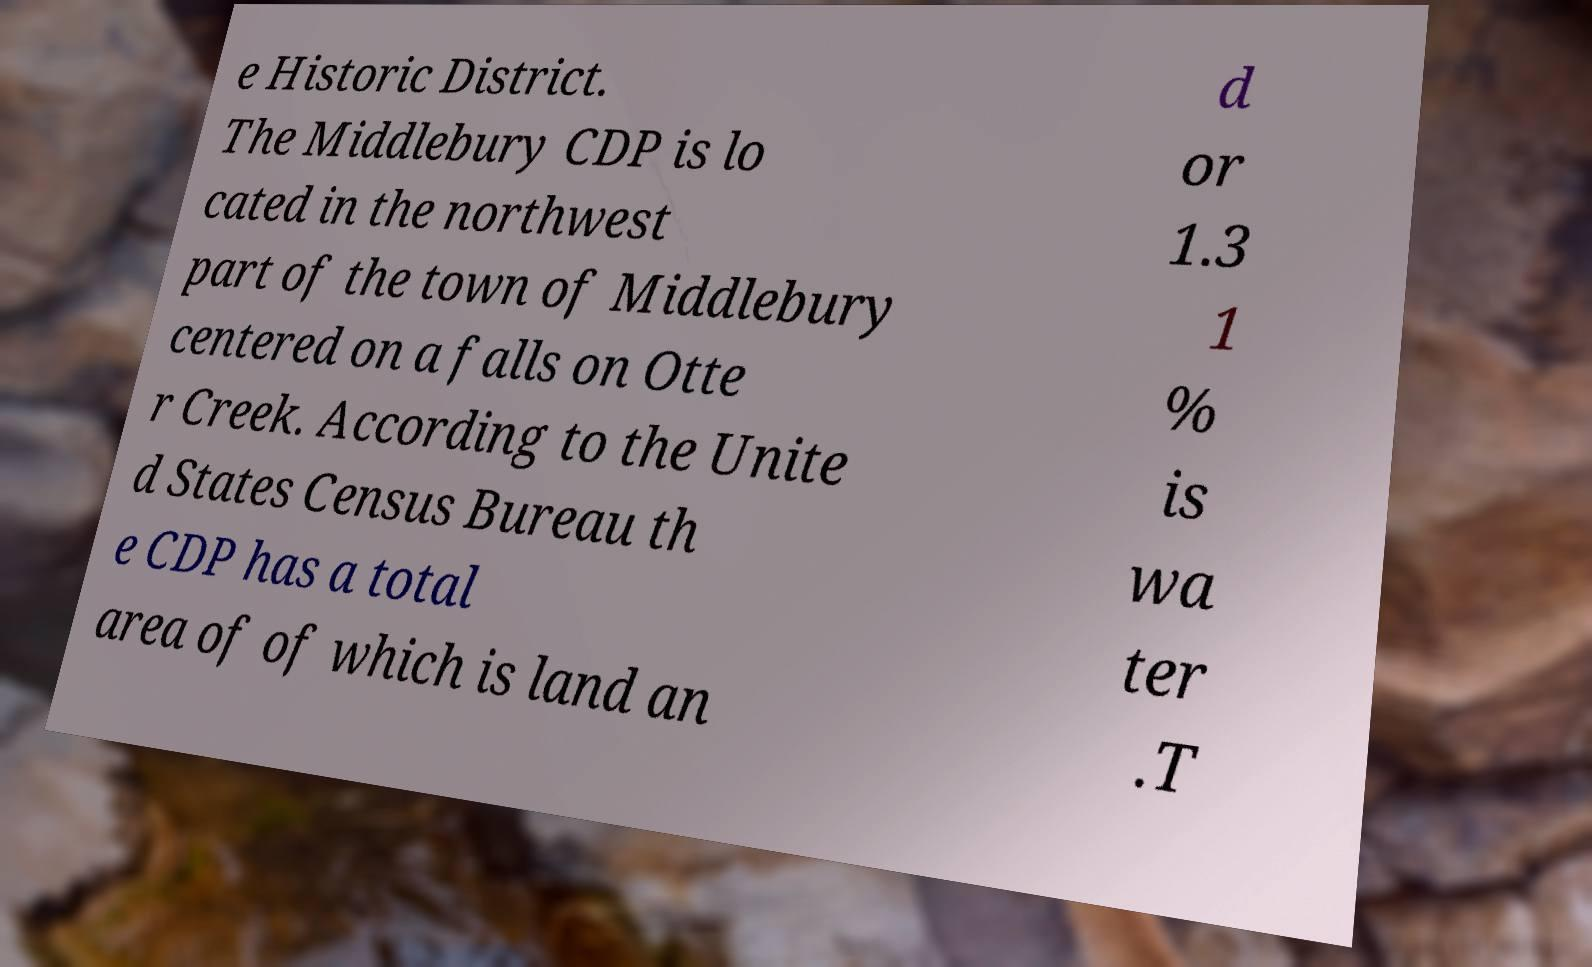I need the written content from this picture converted into text. Can you do that? e Historic District. The Middlebury CDP is lo cated in the northwest part of the town of Middlebury centered on a falls on Otte r Creek. According to the Unite d States Census Bureau th e CDP has a total area of of which is land an d or 1.3 1 % is wa ter .T 